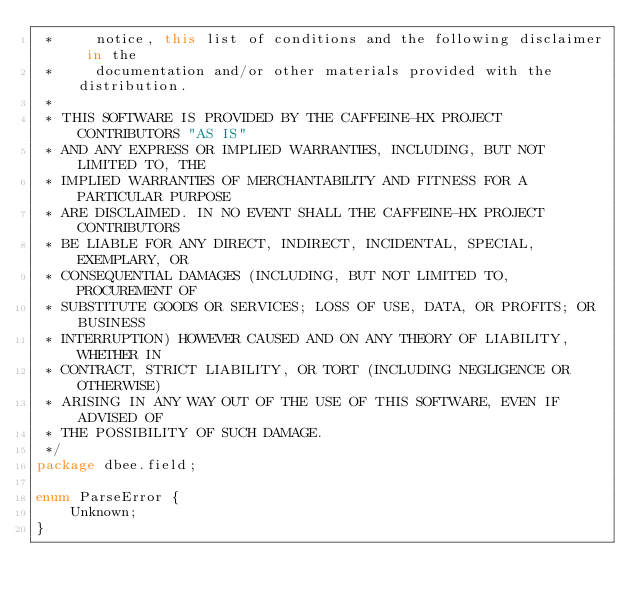Convert code to text. <code><loc_0><loc_0><loc_500><loc_500><_Haxe_> *     notice, this list of conditions and the following disclaimer in the
 *     documentation and/or other materials provided with the distribution.
 *
 * THIS SOFTWARE IS PROVIDED BY THE CAFFEINE-HX PROJECT CONTRIBUTORS "AS IS"
 * AND ANY EXPRESS OR IMPLIED WARRANTIES, INCLUDING, BUT NOT LIMITED TO, THE
 * IMPLIED WARRANTIES OF MERCHANTABILITY AND FITNESS FOR A PARTICULAR PURPOSE
 * ARE DISCLAIMED. IN NO EVENT SHALL THE CAFFEINE-HX PROJECT CONTRIBUTORS
 * BE LIABLE FOR ANY DIRECT, INDIRECT, INCIDENTAL, SPECIAL, EXEMPLARY, OR
 * CONSEQUENTIAL DAMAGES (INCLUDING, BUT NOT LIMITED TO, PROCUREMENT OF
 * SUBSTITUTE GOODS OR SERVICES; LOSS OF USE, DATA, OR PROFITS; OR BUSINESS
 * INTERRUPTION) HOWEVER CAUSED AND ON ANY THEORY OF LIABILITY, WHETHER IN
 * CONTRACT, STRICT LIABILITY, OR TORT (INCLUDING NEGLIGENCE OR OTHERWISE)
 * ARISING IN ANY WAY OUT OF THE USE OF THIS SOFTWARE, EVEN IF ADVISED OF
 * THE POSSIBILITY OF SUCH DAMAGE.
 */
package dbee.field;

enum ParseError {
	Unknown;
}
</code> 